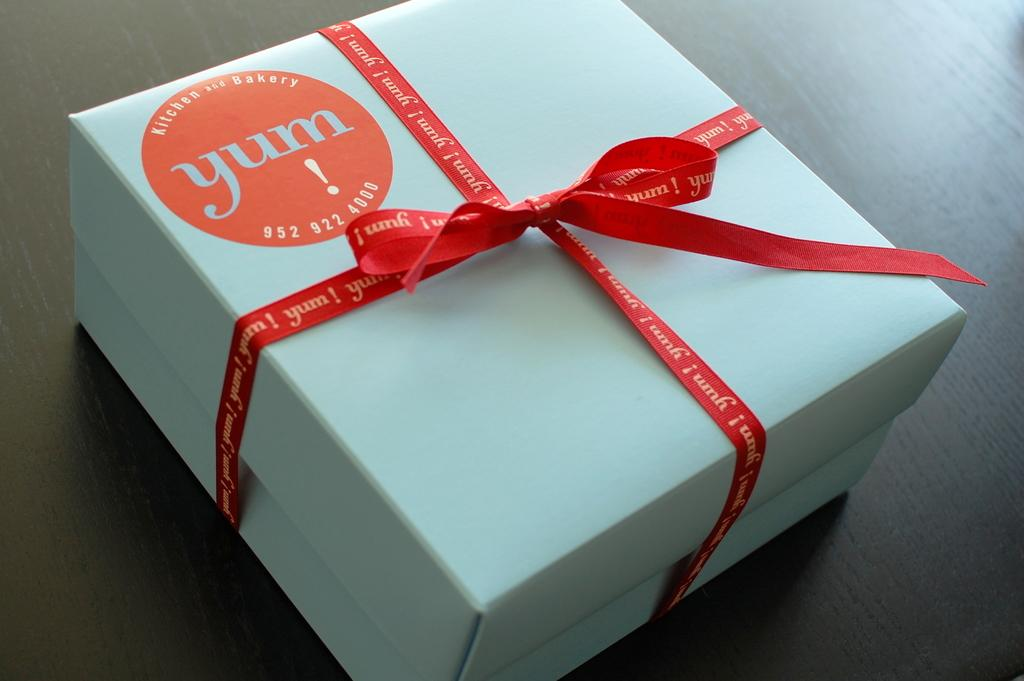<image>
Render a clear and concise summary of the photo. A white box with a red "Yum" sticker on the front is tied with a red ribbon 